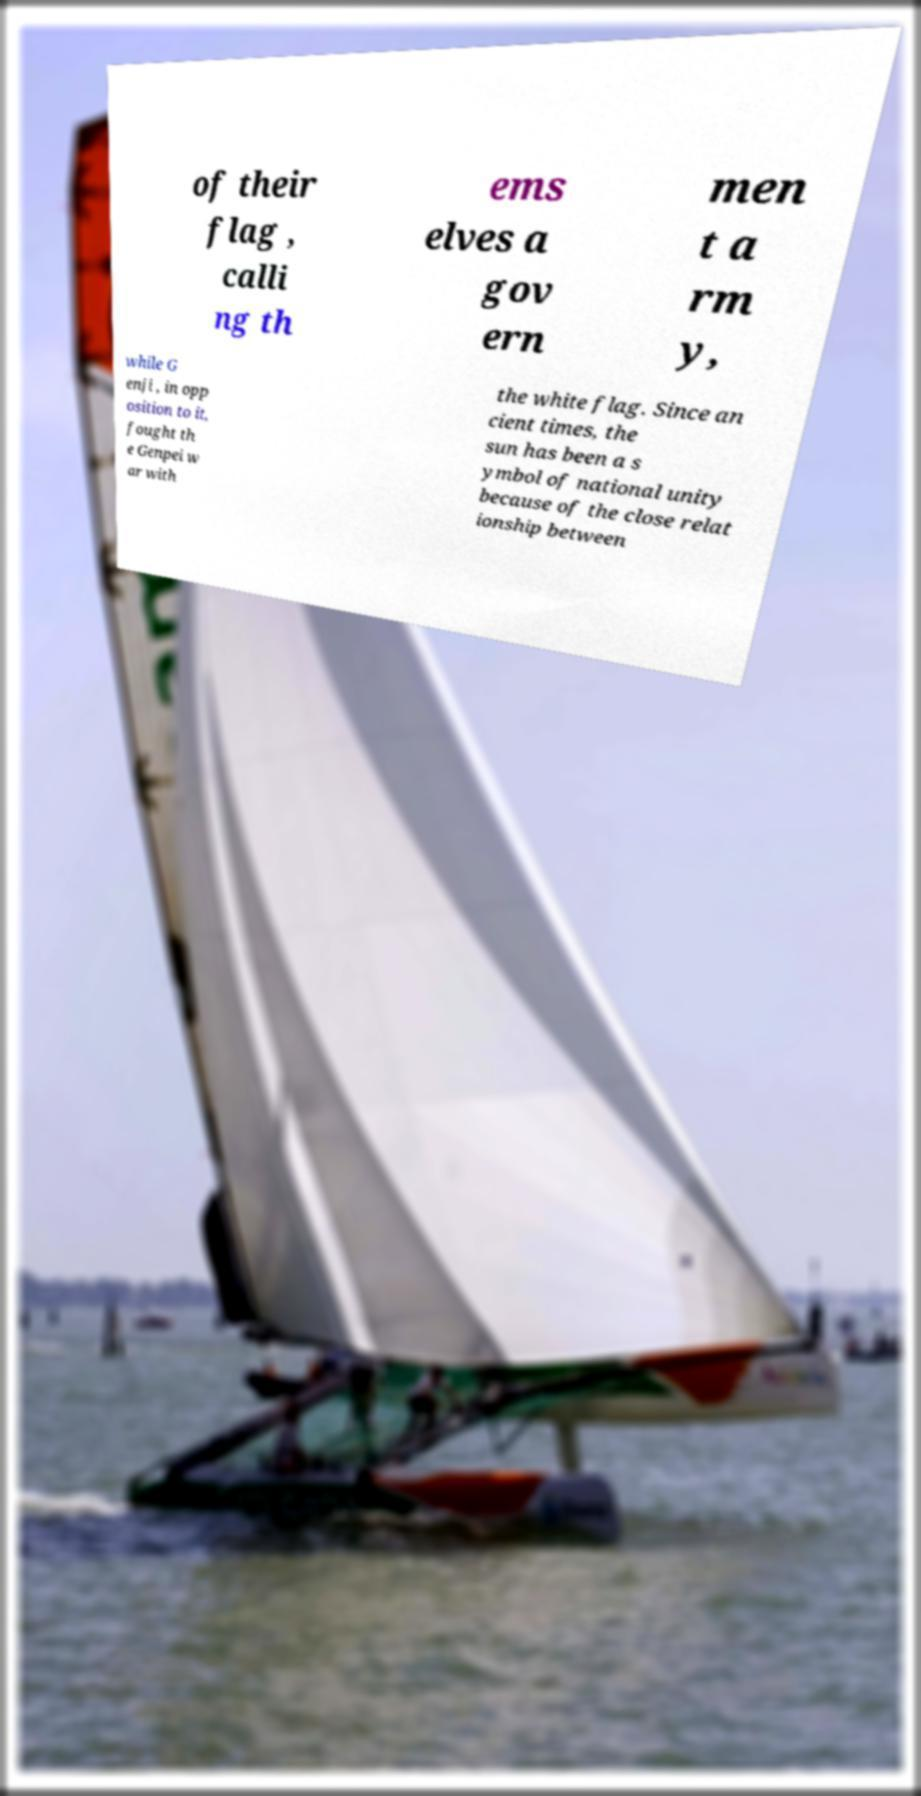For documentation purposes, I need the text within this image transcribed. Could you provide that? of their flag , calli ng th ems elves a gov ern men t a rm y, while G enji , in opp osition to it, fought th e Genpei w ar with the white flag. Since an cient times, the sun has been a s ymbol of national unity because of the close relat ionship between 